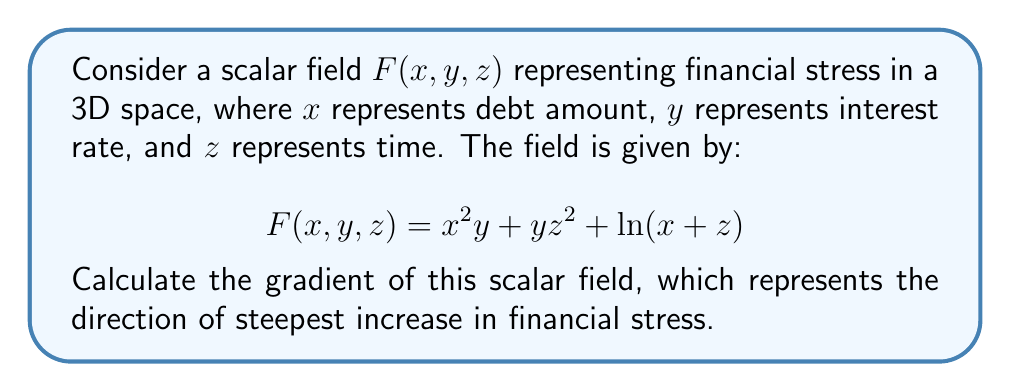Teach me how to tackle this problem. To calculate the gradient of the scalar field $F(x, y, z)$, we need to find the partial derivatives with respect to each variable:

1. Partial derivative with respect to $x$:
   $$\frac{\partial F}{\partial x} = 2xy + \frac{1}{x+z}$$

2. Partial derivative with respect to $y$:
   $$\frac{\partial F}{\partial y} = x^2 + z^2$$

3. Partial derivative with respect to $z$:
   $$\frac{\partial F}{\partial z} = 2yz + \frac{1}{x+z}$$

The gradient is a vector field composed of these partial derivatives:

$$\nabla F = \left(\frac{\partial F}{\partial x}, \frac{\partial F}{\partial y}, \frac{\partial F}{\partial z}\right)$$

Therefore, the gradient of the scalar field $F(x, y, z)$ is:

$$\nabla F = \left(2xy + \frac{1}{x+z}, x^2 + z^2, 2yz + \frac{1}{x+z}\right)$$
Answer: $$\nabla F = \left(2xy + \frac{1}{x+z}, x^2 + z^2, 2yz + \frac{1}{x+z}\right)$$ 